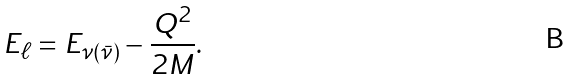<formula> <loc_0><loc_0><loc_500><loc_500>E _ { \ell } = E _ { \nu ( \bar { \nu } ) } - \frac { Q ^ { 2 } } { 2 M } .</formula> 